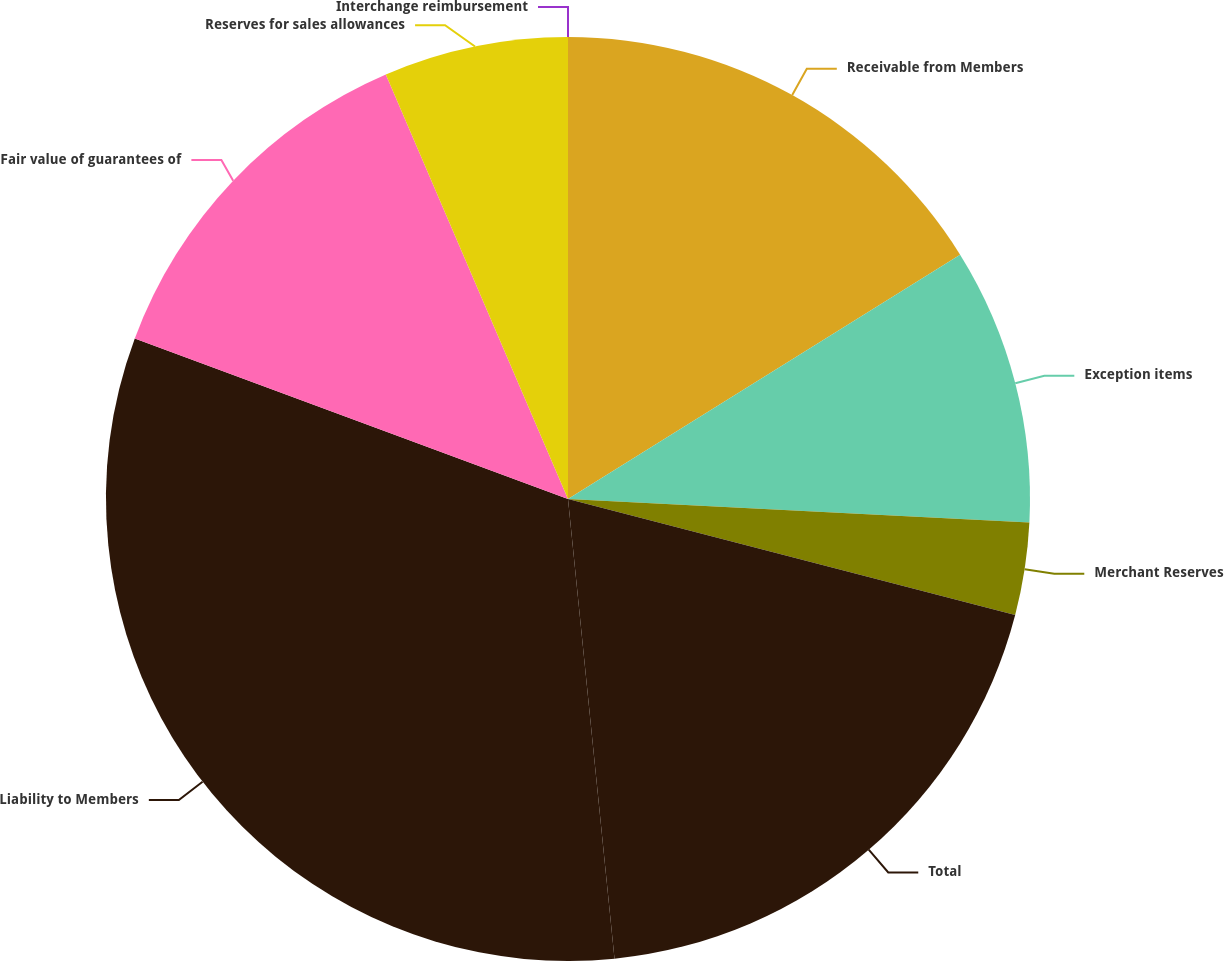Convert chart. <chart><loc_0><loc_0><loc_500><loc_500><pie_chart><fcel>Interchange reimbursement<fcel>Receivable from Members<fcel>Exception items<fcel>Merchant Reserves<fcel>Total<fcel>Liability to Members<fcel>Fair value of guarantees of<fcel>Reserves for sales allowances<nl><fcel>0.0%<fcel>16.13%<fcel>9.68%<fcel>3.23%<fcel>19.35%<fcel>32.25%<fcel>12.9%<fcel>6.45%<nl></chart> 